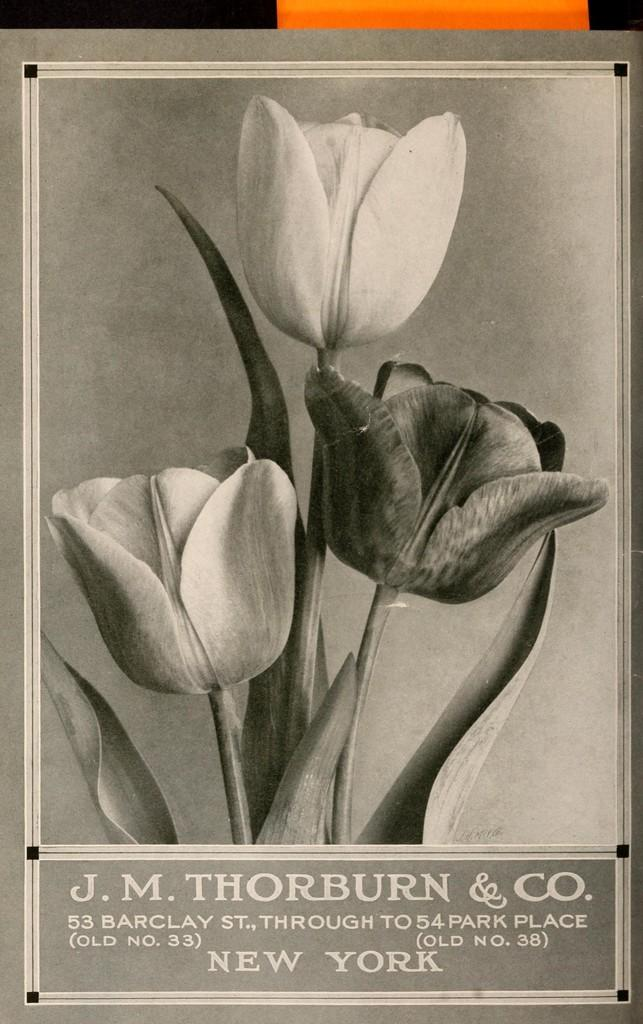What is the color scheme of the image? The image is black and white. What can be seen in the middle of the image? There are flowers in the middle of the image. What is located at the bottom of the image? There is text written at the bottom of the image. How many hands are visible in the image? There are no hands visible in the image, as it is a black and white image with flowers and text. 